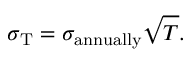Convert formula to latex. <formula><loc_0><loc_0><loc_500><loc_500>\sigma _ { T } = \sigma _ { a n n u a l l y } { \sqrt { T } } .</formula> 